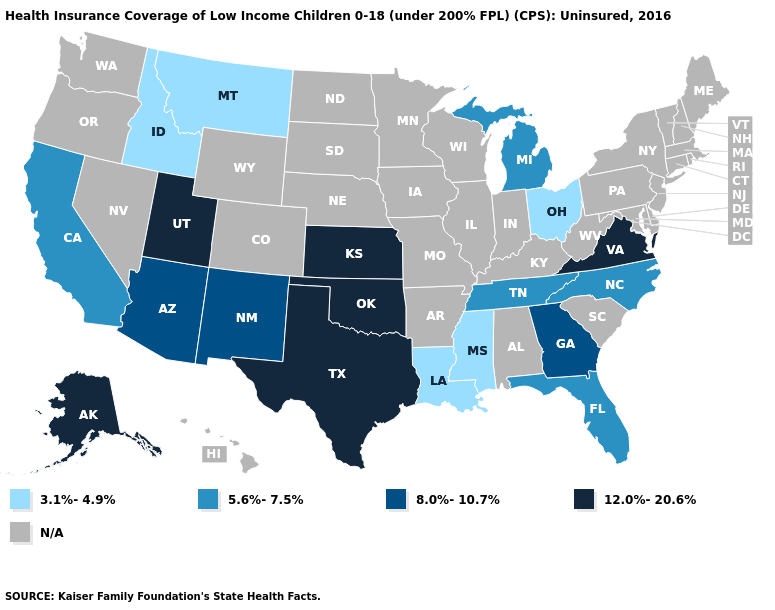Name the states that have a value in the range 5.6%-7.5%?
Write a very short answer. California, Florida, Michigan, North Carolina, Tennessee. What is the lowest value in the West?
Write a very short answer. 3.1%-4.9%. What is the value of North Carolina?
Answer briefly. 5.6%-7.5%. How many symbols are there in the legend?
Be succinct. 5. Is the legend a continuous bar?
Write a very short answer. No. What is the value of Delaware?
Answer briefly. N/A. Does the first symbol in the legend represent the smallest category?
Quick response, please. Yes. Name the states that have a value in the range 3.1%-4.9%?
Short answer required. Idaho, Louisiana, Mississippi, Montana, Ohio. Does Alaska have the highest value in the USA?
Concise answer only. Yes. Which states have the highest value in the USA?
Be succinct. Alaska, Kansas, Oklahoma, Texas, Utah, Virginia. What is the lowest value in the South?
Concise answer only. 3.1%-4.9%. What is the value of Iowa?
Answer briefly. N/A. Name the states that have a value in the range 8.0%-10.7%?
Answer briefly. Arizona, Georgia, New Mexico. Among the states that border Oklahoma , which have the lowest value?
Write a very short answer. New Mexico. Does Mississippi have the lowest value in the USA?
Give a very brief answer. Yes. 